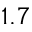Convert formula to latex. <formula><loc_0><loc_0><loc_500><loc_500>1 . 7</formula> 